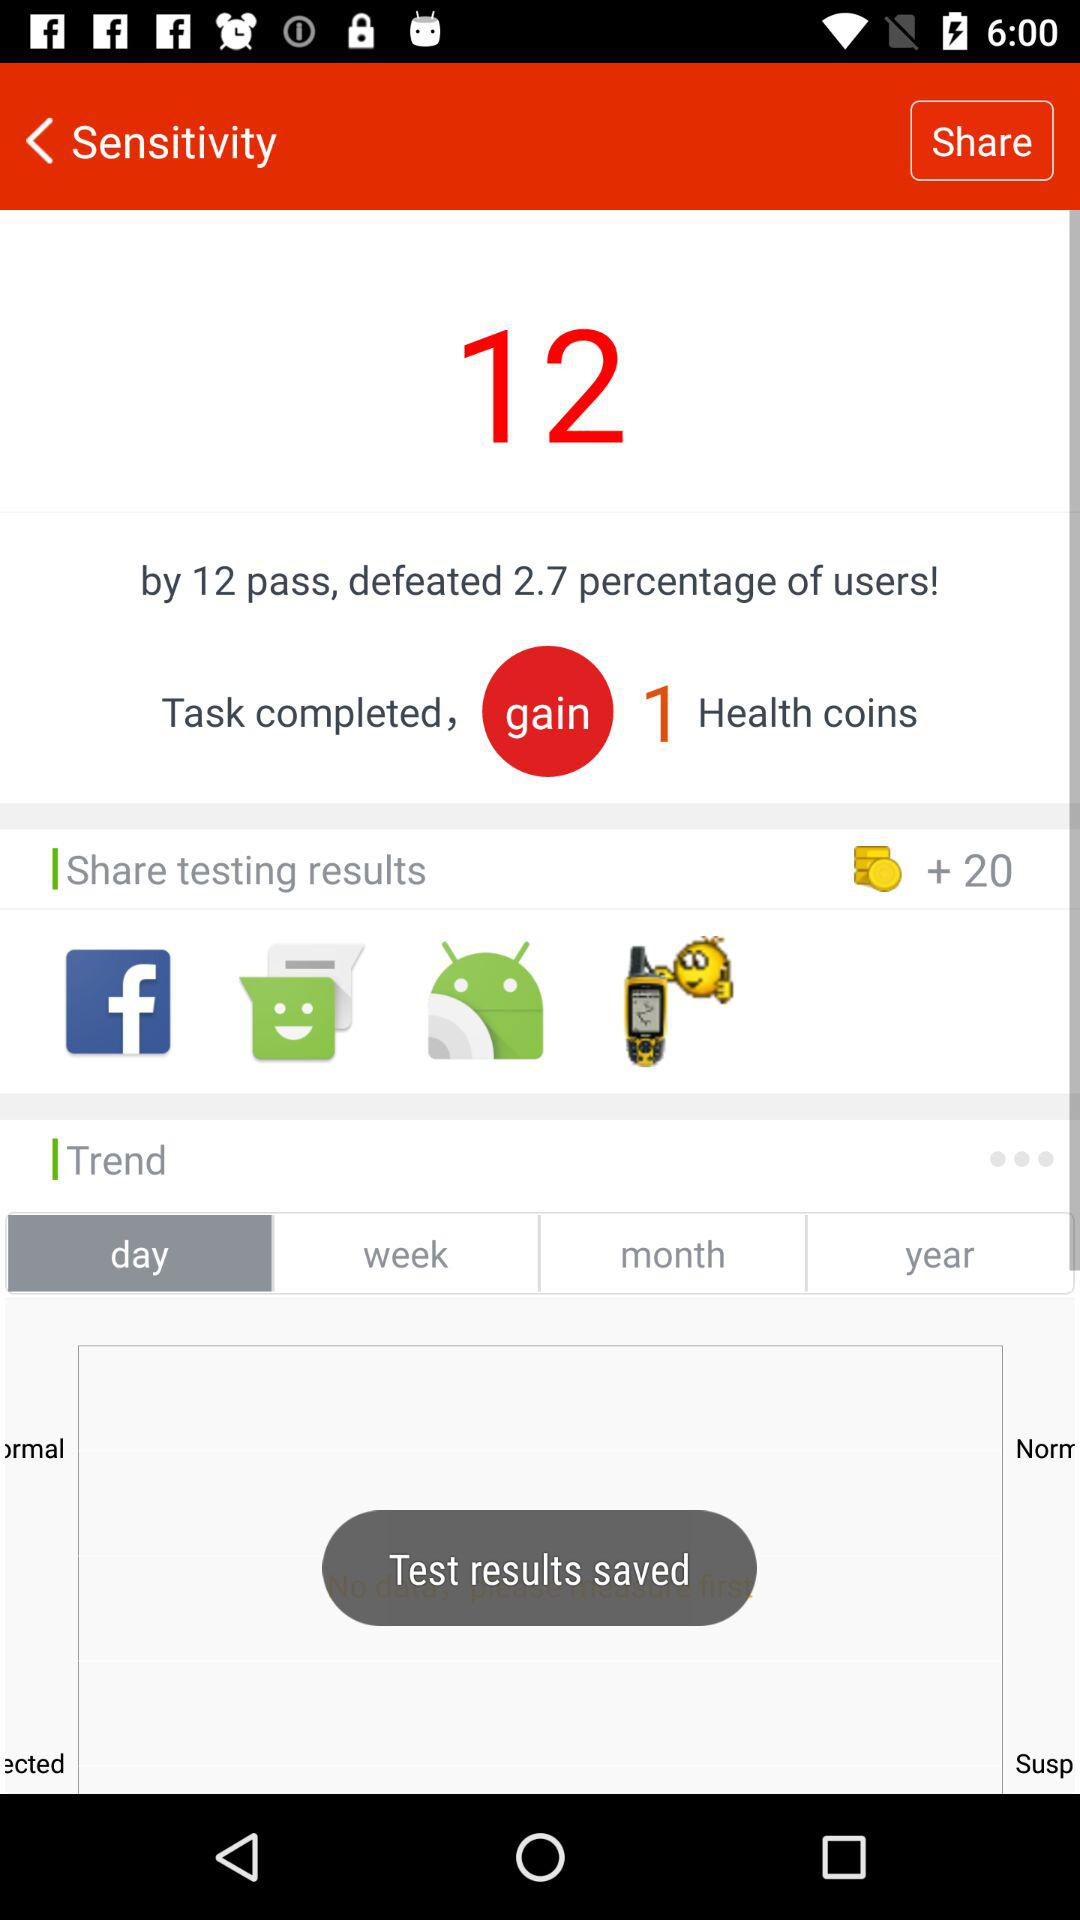How many more task did you complete than the average user?
Answer the question using a single word or phrase. 12 